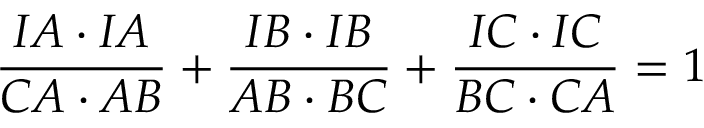Convert formula to latex. <formula><loc_0><loc_0><loc_500><loc_500>{ \frac { I A \cdot I A } { C A \cdot A B } } + { \frac { I B \cdot I B } { A B \cdot B C } } + { \frac { I C \cdot I C } { B C \cdot C A } } = 1</formula> 